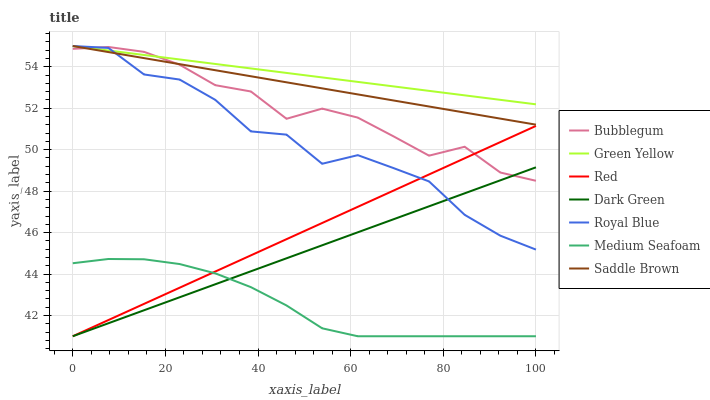Does Medium Seafoam have the minimum area under the curve?
Answer yes or no. Yes. Does Green Yellow have the maximum area under the curve?
Answer yes or no. Yes. Does Saddle Brown have the minimum area under the curve?
Answer yes or no. No. Does Saddle Brown have the maximum area under the curve?
Answer yes or no. No. Is Green Yellow the smoothest?
Answer yes or no. Yes. Is Royal Blue the roughest?
Answer yes or no. Yes. Is Saddle Brown the smoothest?
Answer yes or no. No. Is Saddle Brown the roughest?
Answer yes or no. No. Does Medium Seafoam have the lowest value?
Answer yes or no. Yes. Does Saddle Brown have the lowest value?
Answer yes or no. No. Does Green Yellow have the highest value?
Answer yes or no. Yes. Does Medium Seafoam have the highest value?
Answer yes or no. No. Is Medium Seafoam less than Royal Blue?
Answer yes or no. Yes. Is Saddle Brown greater than Dark Green?
Answer yes or no. Yes. Does Green Yellow intersect Saddle Brown?
Answer yes or no. Yes. Is Green Yellow less than Saddle Brown?
Answer yes or no. No. Is Green Yellow greater than Saddle Brown?
Answer yes or no. No. Does Medium Seafoam intersect Royal Blue?
Answer yes or no. No. 